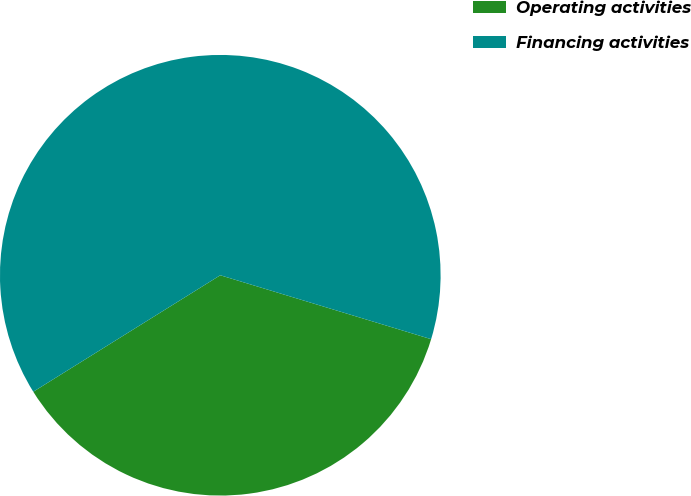Convert chart. <chart><loc_0><loc_0><loc_500><loc_500><pie_chart><fcel>Operating activities<fcel>Financing activities<nl><fcel>36.45%<fcel>63.55%<nl></chart> 